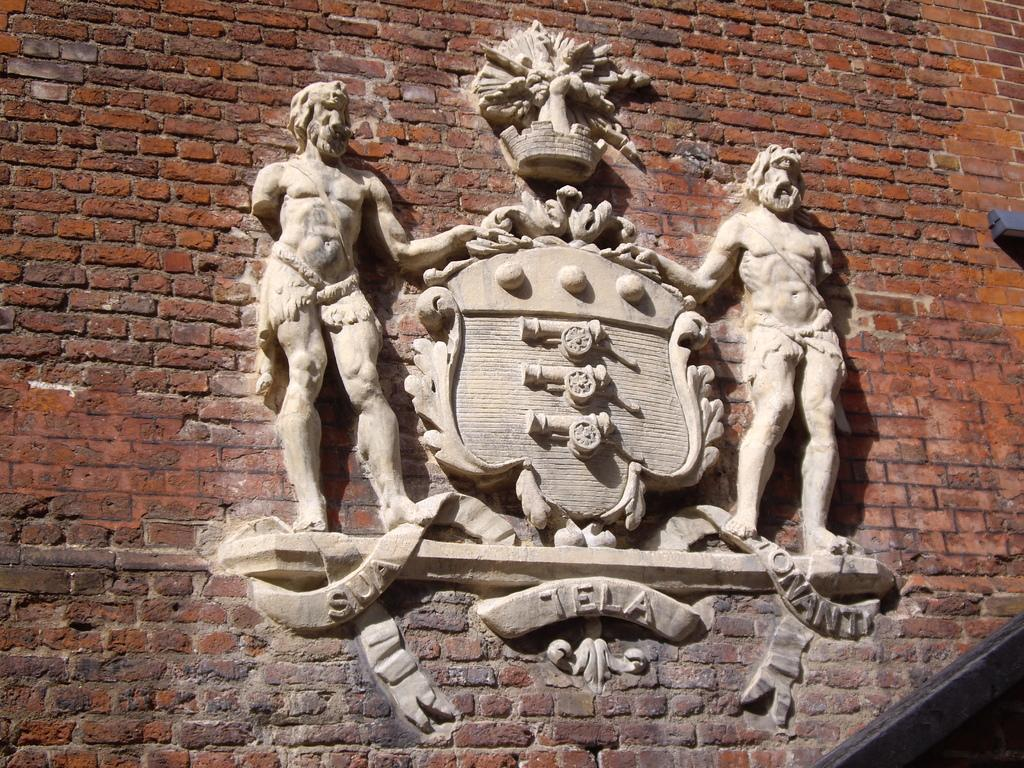What type of art is featured in the image? There are sculptures in the image. Where are the sculptures located? The sculptures are on a brick wall. What type of fabric is draped over the sculptures in the image? There is no fabric draped over the sculptures in the image. How many maids are attending to the sculptures in the image? There are no maids present in the image. 